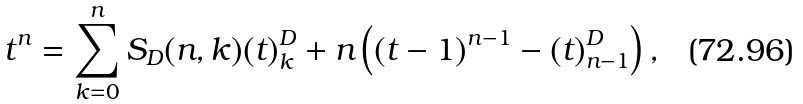Convert formula to latex. <formula><loc_0><loc_0><loc_500><loc_500>t ^ { n } = \sum _ { k = 0 } ^ { n } S _ { D } ( n , k ) ( t ) _ { k } ^ { D } + n \left ( ( t - 1 ) ^ { n - 1 } - ( t ) _ { n - 1 } ^ { D } \right ) ,</formula> 